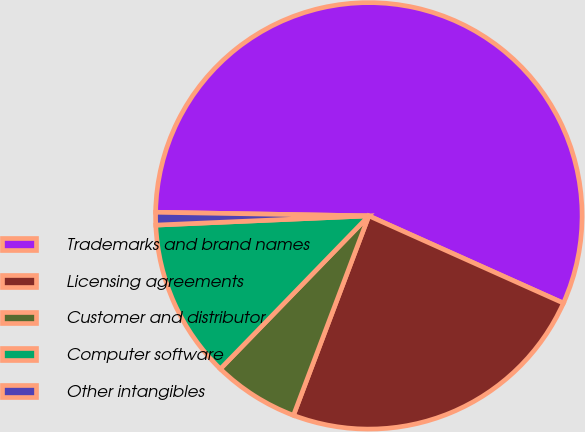<chart> <loc_0><loc_0><loc_500><loc_500><pie_chart><fcel>Trademarks and brand names<fcel>Licensing agreements<fcel>Customer and distributor<fcel>Computer software<fcel>Other intangibles<nl><fcel>56.44%<fcel>24.04%<fcel>6.51%<fcel>12.05%<fcel>0.96%<nl></chart> 